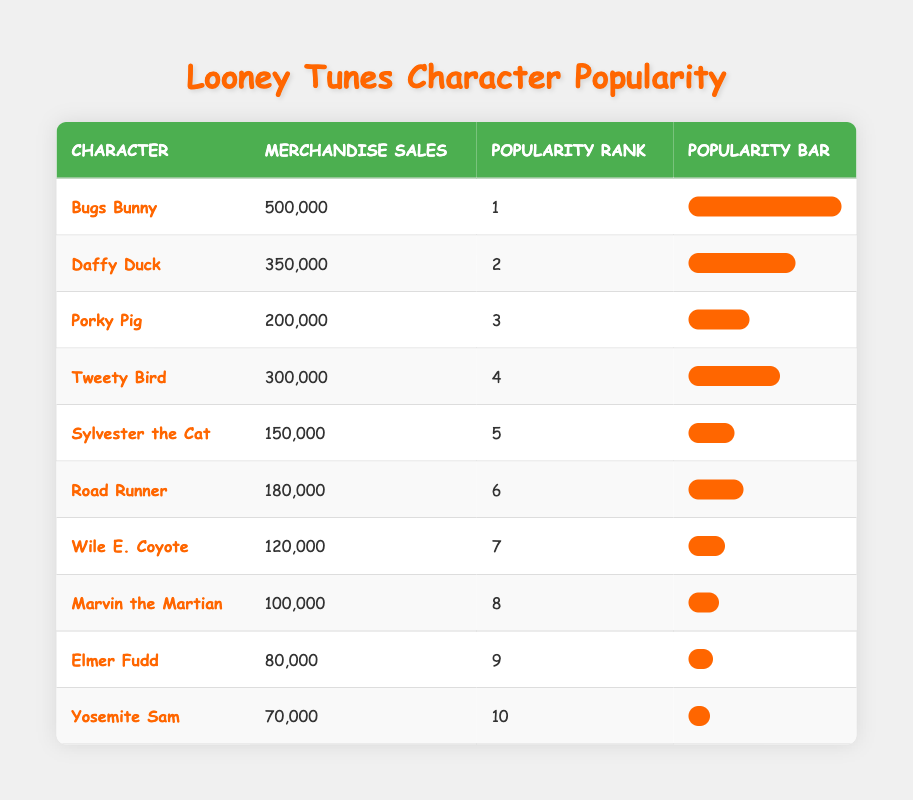What is the merchandise sales of Bugs Bunny? According to the table, Bugs Bunny has merchandise sales of 500,000.
Answer: 500,000 Which character has the lowest merchandise sales? By checking the Merchandise Sales column, Yosemite Sam has the lowest sales at 70,000.
Answer: Yosemite Sam Is Tweety Bird more popular than Porky Pig? Tweety Bird has a popularity rank of 4, while Porky Pig has a rank of 3. Since a lower rank indicates higher popularity, Tweety Bird is less popular than Porky Pig.
Answer: No What is the total merchandise sales of the top three characters? Adding the sales of the top three characters: 500,000 (Bugs Bunny) + 350,000 (Daffy Duck) + 200,000 (Porky Pig) totals to 1,050,000.
Answer: 1,050,000 How many characters have merchandise sales over 150,000? The characters with sales over 150,000 are Bugs Bunny, Daffy Duck, Porky Pig, Tweety Bird, and Road Runner, totaling five characters.
Answer: 5 Which character is ranked 5th and what are its merchandise sales? The table shows that Sylvester the Cat is ranked 5th and has merchandise sales of 150,000.
Answer: Sylvester the Cat, 150,000 Is it true that Marvin the Martian has higher merchandise sales than Elmer Fudd? Checking the sales figures, Marvin the Martian has 100,000 in sales while Elmer Fudd has 80,000, confirming that Marvin has higher sales.
Answer: Yes What percentage of the highest seller's sales does Daffy Duck have? Daffy Duck's sales of 350,000 are divided by Bugs Bunny's 500,000 and then multiplied by 100 to find the percentage: (350,000 / 500,000) * 100 = 70%.
Answer: 70% 